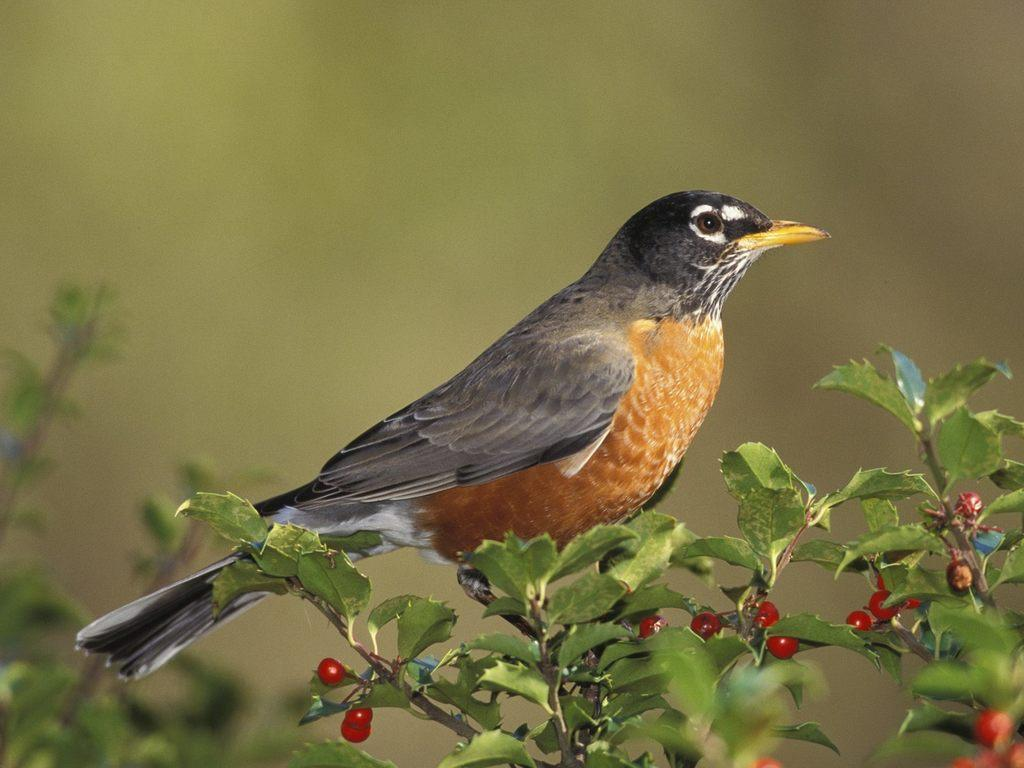What is present in the picture? There is a plant in the picture. What can be observed about the plant? The plant has small fruits. Is there any other living creature in the image? Yes, there is a bird standing on the plant. What type of disease is affecting the plant in the image? There is no indication of any disease affecting the plant in the image. What behavior is the bird exhibiting in the image? The bird is simply standing on the plant, and no specific behavior is evident from the image. 